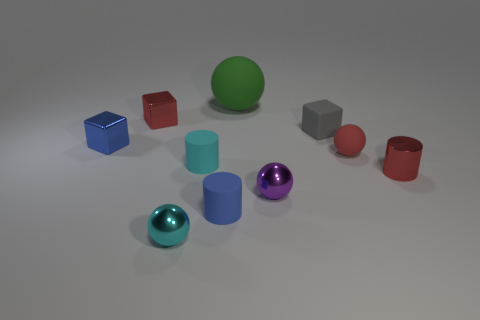Subtract all red metallic blocks. How many blocks are left? 2 Subtract all cyan cylinders. How many cylinders are left? 2 Subtract all spheres. How many objects are left? 6 Subtract 1 balls. How many balls are left? 3 Subtract 1 green spheres. How many objects are left? 9 Subtract all green cubes. Subtract all green spheres. How many cubes are left? 3 Subtract all small red shiny cylinders. Subtract all tiny blue cubes. How many objects are left? 8 Add 4 gray rubber things. How many gray rubber things are left? 5 Add 7 big green rubber objects. How many big green rubber objects exist? 8 